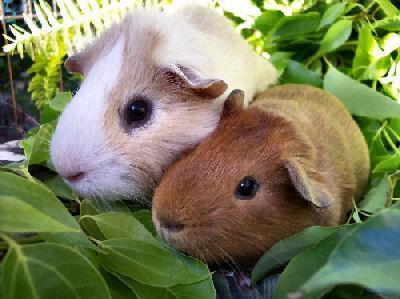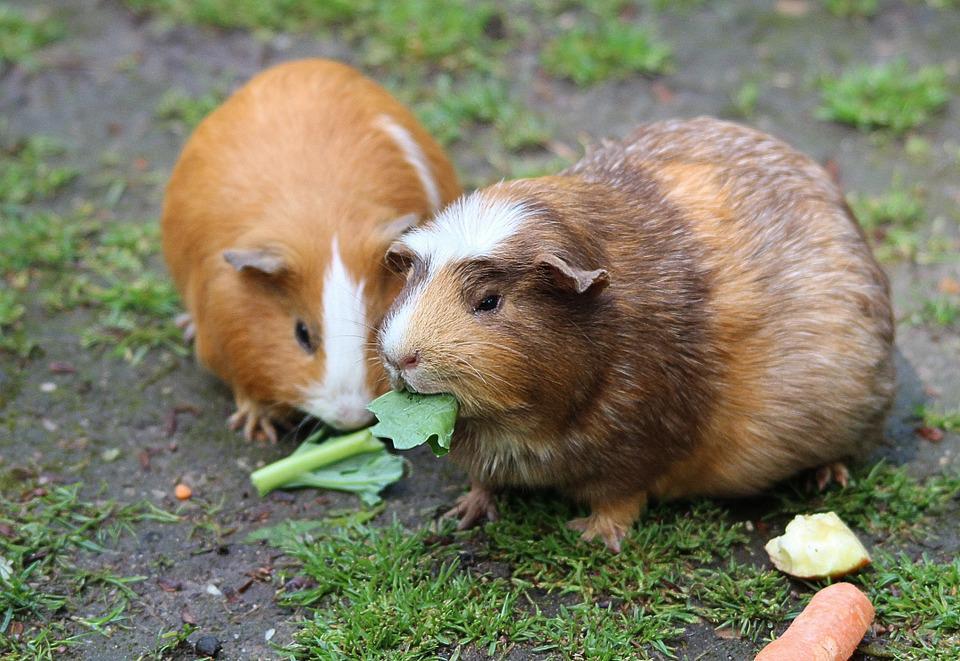The first image is the image on the left, the second image is the image on the right. For the images shown, is this caption "One of the animals is brown." true? Answer yes or no. Yes. 